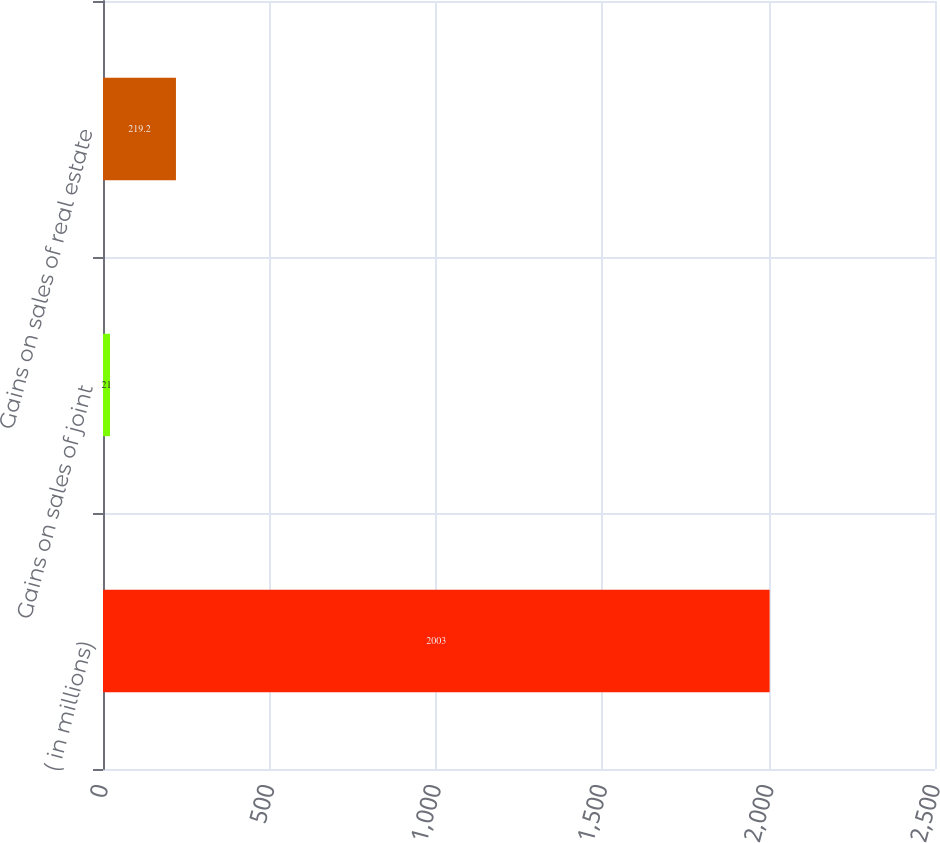<chart> <loc_0><loc_0><loc_500><loc_500><bar_chart><fcel>( in millions)<fcel>Gains on sales of joint<fcel>Gains on sales of real estate<nl><fcel>2003<fcel>21<fcel>219.2<nl></chart> 